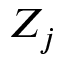<formula> <loc_0><loc_0><loc_500><loc_500>Z _ { j }</formula> 